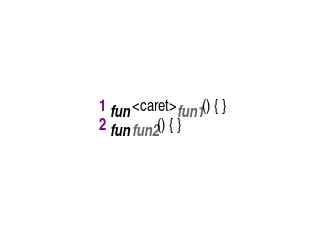Convert code to text. <code><loc_0><loc_0><loc_500><loc_500><_Kotlin_>fun <caret>fun1() { }
fun fun2() { }
</code> 